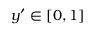<formula> <loc_0><loc_0><loc_500><loc_500>y ^ { \prime } \in [ 0 , 1 ]</formula> 